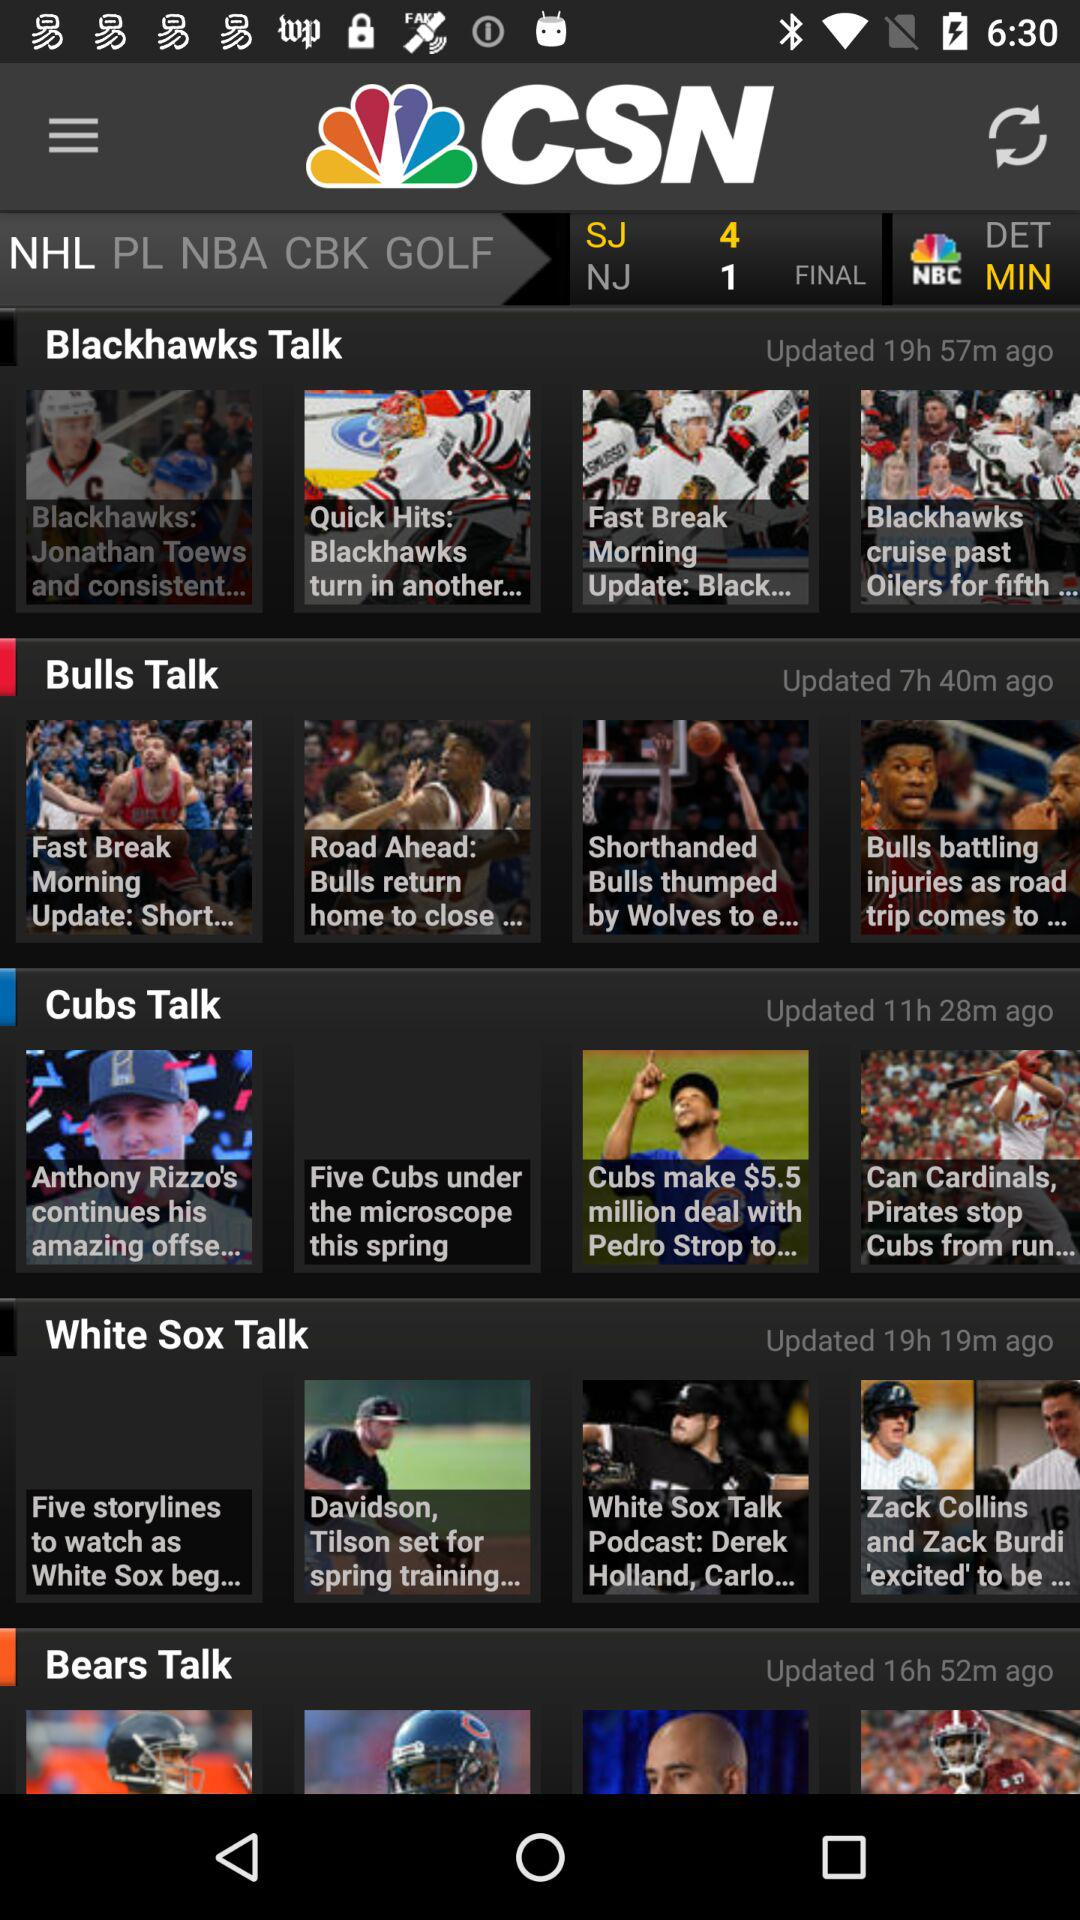What's the selected game category? The selected game category is "NHL". 